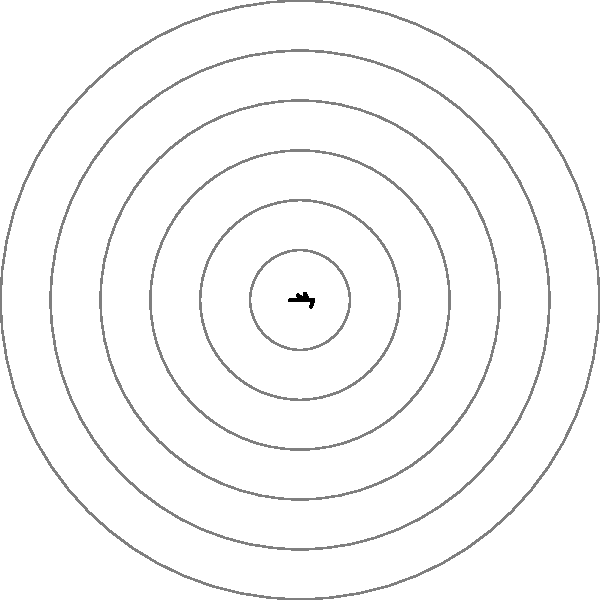As a pharmaceutical sales representative, you've been tasked with analyzing the sales performance across different territories using a polar rose diagram. The diagram shows six territories, each represented by a "petal" extending from the center. If the company's goal is to have balanced sales across all territories, which territory requires the most attention to improve its performance relative to the others? To determine which territory requires the most attention, we need to compare the lengths of the petals in the polar rose diagram. Each petal represents a territory, and its length corresponds to the sales performance in that territory. A shorter petal indicates lower sales performance.

Step 1: Identify all territories.
The diagram shows six territories, labeled from 1 to 6.

Step 2: Compare the lengths of the petals.
Territory 1: Moderate length
Territory 2: Longest petal
Territory 3: Slightly shorter than Territory 2
Territory 4: Shortest petal
Territory 5: Second longest petal
Territory 6: Moderate length, similar to Territory 1

Step 3: Identify the shortest petal.
The shortest petal corresponds to Territory 4.

Step 4: Interpret the result.
Since Territory 4 has the shortest petal, it represents the area with the lowest sales performance relative to the other territories. Therefore, this territory requires the most attention to improve its performance and achieve a more balanced sales distribution across all territories.
Answer: Territory 4 